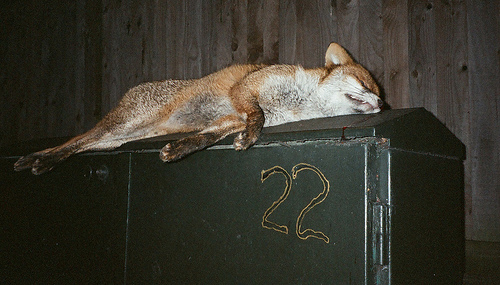<image>
Is the fox behind the wall? No. The fox is not behind the wall. From this viewpoint, the fox appears to be positioned elsewhere in the scene. Is the fox above the box? No. The fox is not positioned above the box. The vertical arrangement shows a different relationship. 